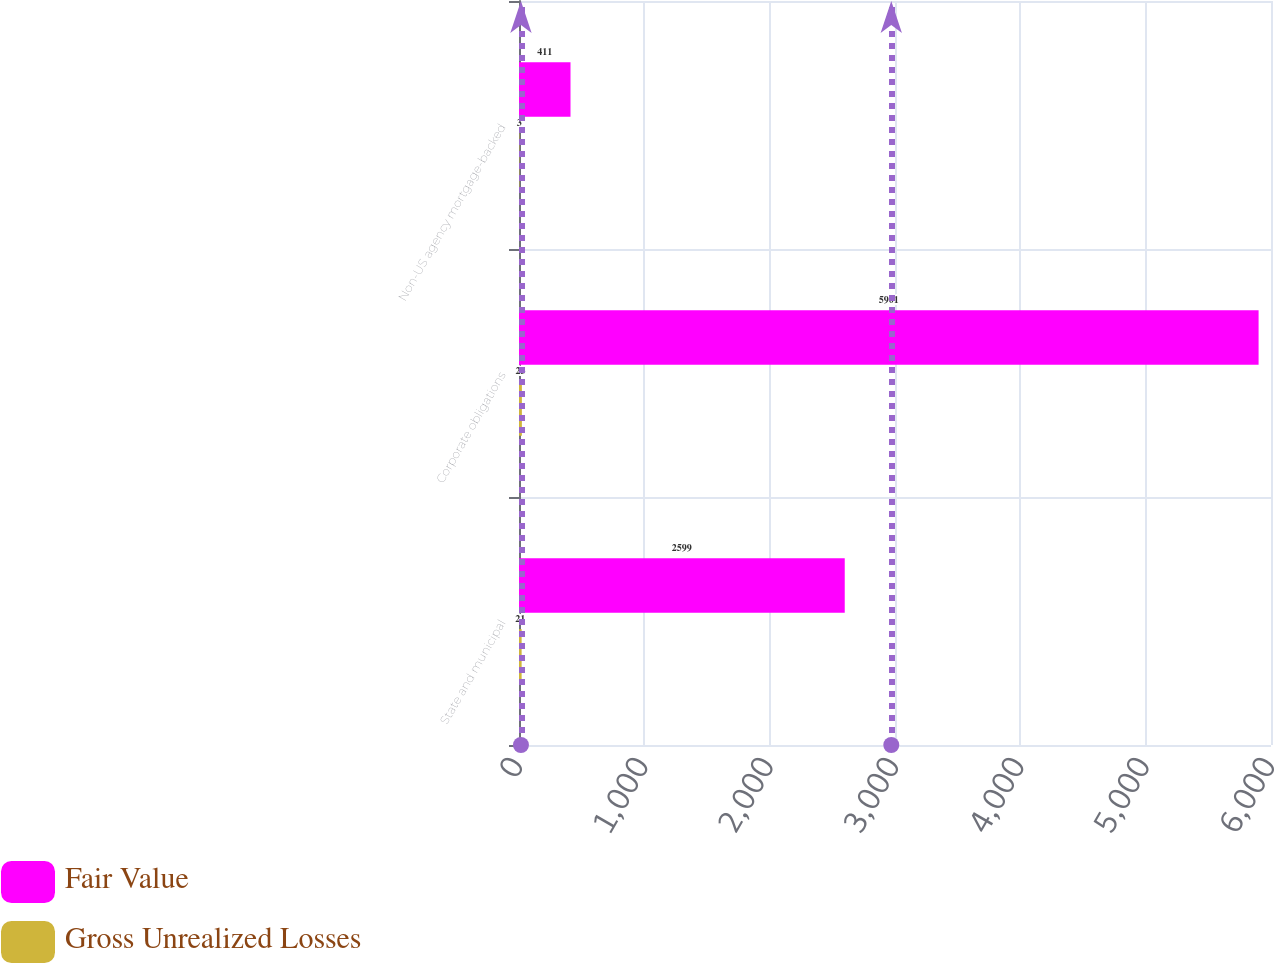Convert chart to OTSL. <chart><loc_0><loc_0><loc_500><loc_500><stacked_bar_chart><ecel><fcel>State and municipal<fcel>Corporate obligations<fcel>Non-US agency mortgage-backed<nl><fcel>Fair Value<fcel>2599<fcel>5901<fcel>411<nl><fcel>Gross Unrealized Losses<fcel>21<fcel>23<fcel>3<nl></chart> 